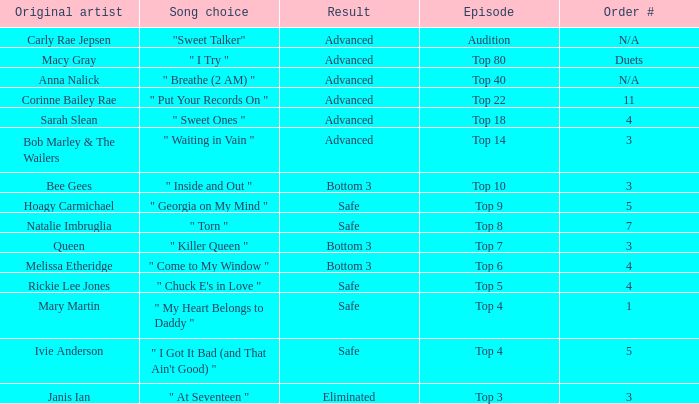Which one of the songs was originally performed by Rickie Lee Jones? " Chuck E's in Love ". 